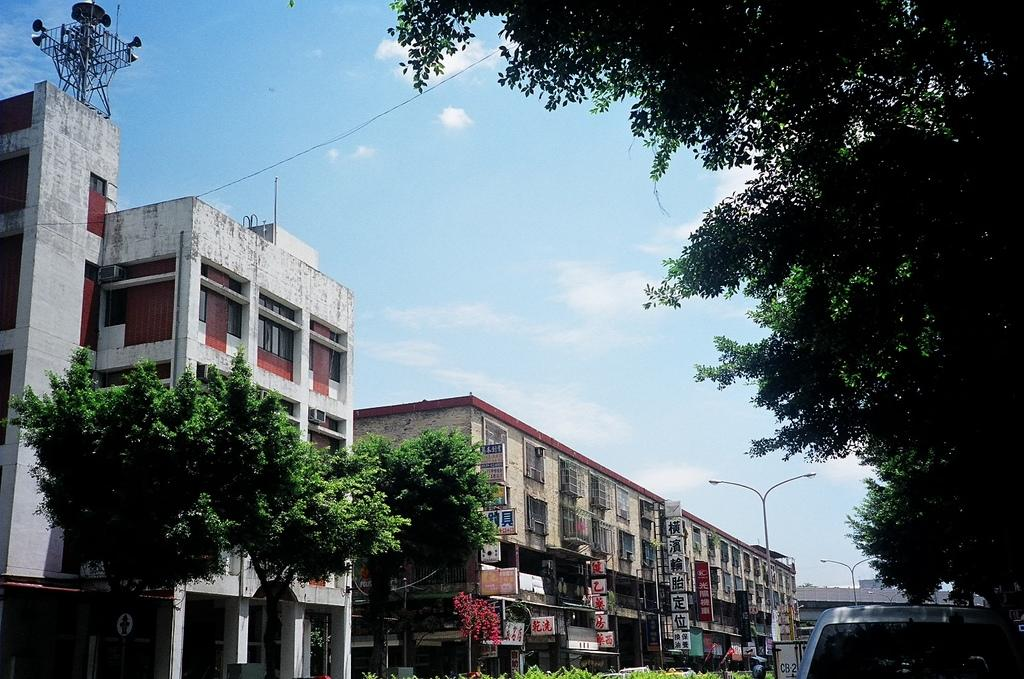What type of natural elements can be seen in the image? There are trees in the image. What man-made object is present in the image? There is a car in the image. What type of structures can be seen in the image? There are buildings in the image. What other man-made objects can be seen in the image? There are poles in the image. What is connecting the poles in the image? There is wire in the image connecting the poles. What is visible in the background of the image? The sky is visible in the image, and there are clouds in the sky. What type of mass is being cast in the image? There is no mention of a mass or casting process in the image. How does the car stop in the image? The image does not show the car in motion, so it is not possible to determine how it stops. 